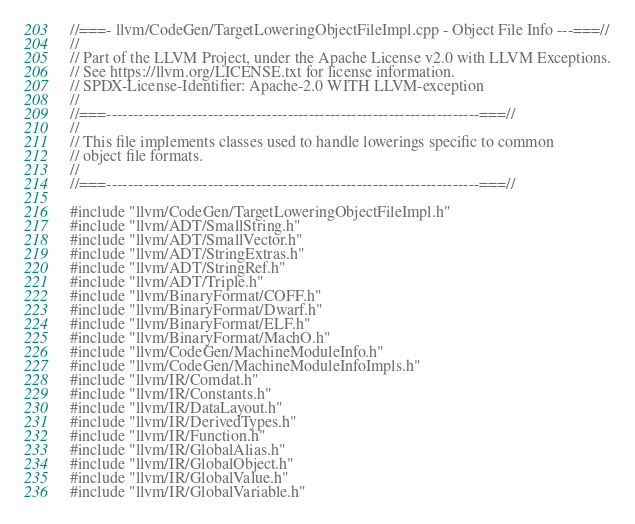<code> <loc_0><loc_0><loc_500><loc_500><_C++_>//===- llvm/CodeGen/TargetLoweringObjectFileImpl.cpp - Object File Info ---===//
//
// Part of the LLVM Project, under the Apache License v2.0 with LLVM Exceptions.
// See https://llvm.org/LICENSE.txt for license information.
// SPDX-License-Identifier: Apache-2.0 WITH LLVM-exception
//
//===----------------------------------------------------------------------===//
//
// This file implements classes used to handle lowerings specific to common
// object file formats.
//
//===----------------------------------------------------------------------===//

#include "llvm/CodeGen/TargetLoweringObjectFileImpl.h"
#include "llvm/ADT/SmallString.h"
#include "llvm/ADT/SmallVector.h"
#include "llvm/ADT/StringExtras.h"
#include "llvm/ADT/StringRef.h"
#include "llvm/ADT/Triple.h"
#include "llvm/BinaryFormat/COFF.h"
#include "llvm/BinaryFormat/Dwarf.h"
#include "llvm/BinaryFormat/ELF.h"
#include "llvm/BinaryFormat/MachO.h"
#include "llvm/CodeGen/MachineModuleInfo.h"
#include "llvm/CodeGen/MachineModuleInfoImpls.h"
#include "llvm/IR/Comdat.h"
#include "llvm/IR/Constants.h"
#include "llvm/IR/DataLayout.h"
#include "llvm/IR/DerivedTypes.h"
#include "llvm/IR/Function.h"
#include "llvm/IR/GlobalAlias.h"
#include "llvm/IR/GlobalObject.h"
#include "llvm/IR/GlobalValue.h"
#include "llvm/IR/GlobalVariable.h"</code> 